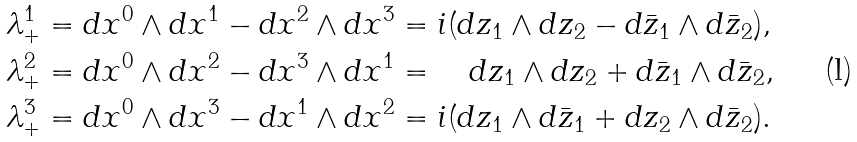Convert formula to latex. <formula><loc_0><loc_0><loc_500><loc_500>\lambda _ { + } ^ { 1 } & = d x ^ { 0 } \wedge d x ^ { 1 } - d x ^ { 2 } \wedge d x ^ { 3 } = i ( d z _ { 1 } \wedge d z _ { 2 } - d \bar { z } _ { 1 } \wedge d \bar { z } _ { 2 } ) , \\ \lambda _ { + } ^ { 2 } & = d x ^ { 0 } \wedge d x ^ { 2 } - d x ^ { 3 } \wedge d x ^ { 1 } = \quad d z _ { 1 } \wedge d z _ { 2 } + d \bar { z } _ { 1 } \wedge d \bar { z } _ { 2 } , \\ \lambda _ { + } ^ { 3 } & = d x ^ { 0 } \wedge d x ^ { 3 } - d x ^ { 1 } \wedge d x ^ { 2 } = i ( d z _ { 1 } \wedge d \bar { z } _ { 1 } + d z _ { 2 } \wedge d \bar { z } _ { 2 } ) .</formula> 